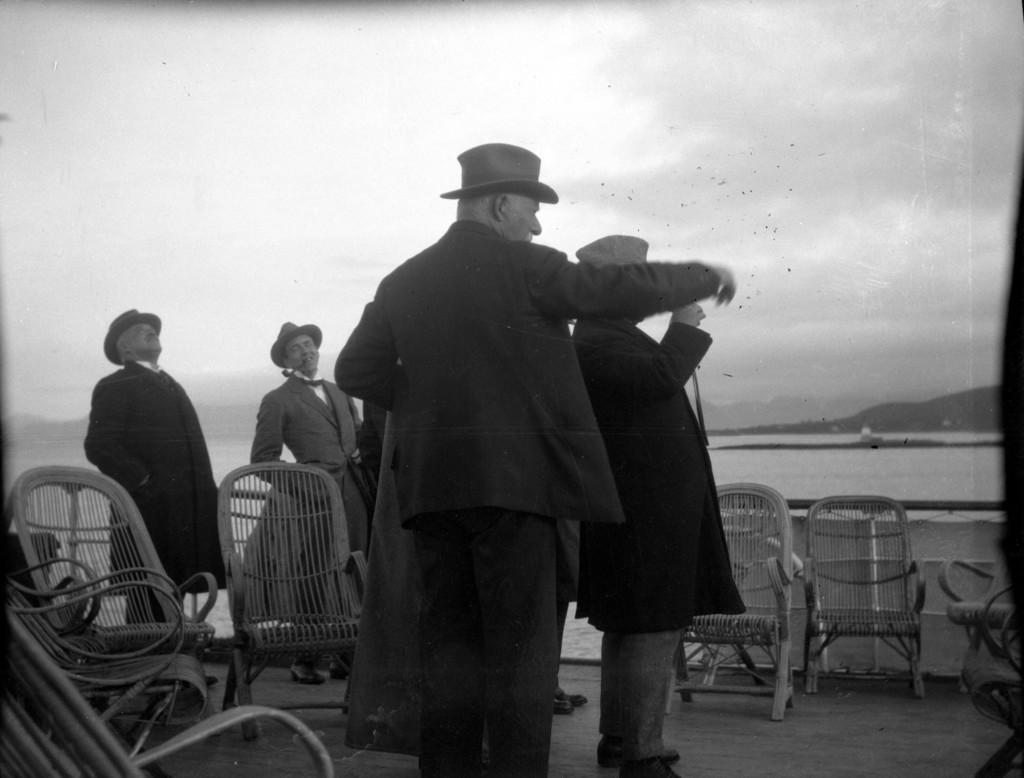What is the color scheme of the image? The image is black and white. What can be seen on the floor in the image? There are people standing on a floor in the image. What type of furniture is present around the people? There are chairs around the people. What natural features can be seen in the background of the image? There is a river, a mountain, and the sky visible in the background of the image. How many dimes are scattered on the floor in the image? There are no dimes present in the image; it features people standing on a floor with chairs around them. Can you describe the wings of the bird in the image? There is no bird with wings present in the image. 